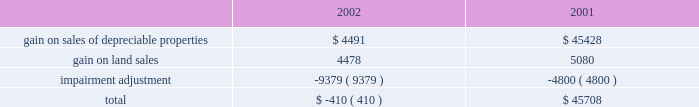Management 2019s discussion and analysis of financial conditionand results of operations d u k e r e a l t y c o r p o r a t i o n 1 1 2 0 0 2 a n n u a l r e p o r t 2022 interest expense on the company 2019s secured debt decreased from $ 30.8 million in 2001 to $ 22.9 million in 2002 as the company paid off $ 13.5 million of secured debt throughout 2002 and experienced lower borrowings on its secured line of credit during 2002 compared to 2001 .
Additionally , the company paid off approximately $ 128.5 million of secured debt throughout 2001 .
2022 interest expense on the company 2019s $ 500 million unsecured line of credit decreased by approximately $ 1.1 million in 2002 compared to 2001 as the company maintained lower balances on the line throughout most of 2002 .
As a result of the above-mentioned items , earnings from rental operations decreased $ 35.0 million from $ 254.1 million for the year ended december 31 , 2001 , to $ 219.1 million for the year ended december 31 , 2002 .
Service operations service operations primarily consist of leasing , management , construction and development services for joint venture properties and properties owned by third parties .
Service operations revenues decreased from $ 80.5 million for the year ended december 31 , 2001 , to $ 68.6 million for the year ended december 31 , 2002 .
The prolonged effect of the slow economy has been the primary factor in the overall decrease in revenues .
The company experienced a decrease of $ 12.7 million in net general contractor revenues because of a decrease in the volume of construction in 2002 , compared to 2001 , as well as slightly lower profit margins .
Property management , maintenance and leasing fee revenues decreased from $ 22.8 million in 2001 to $ 14.3 million in 2002 primarily because of a decrease in landscaping maintenance revenue resulting from the sale of the landscaping operations in the third quarter of 2001 .
Construction management and development activity income represents construction and development fees earned on projects where the company acts as the construction manager along with profits from the company 2019s held for sale program whereby the company develops a property for sale upon completion .
The increase in revenues of $ 10.3 million in 2002 is primarily due to an increase in volume of the sale of properties from the held for sale program .
Service operations expenses decreased from $ 45.3 million in 2001 to $ 38.3 million in 2002 .
The decrease is attributable to the decrease in construction and development activity and the reduced overhead costs as a result of the sale of the landscape business in 2001 .
As a result of the above , earnings from service operations decreased from $ 35.1 million for the year ended december 31 , 2001 , to $ 30.3 million for the year ended december 31 , 2002 .
General and administrative expense general and administrative expense increased from $ 15.6 million in 2001 to $ 25.4 million for the year ended december 31 , 2002 .
The company has been successful reducing total operating and administration costs ; however , reduced construction and development activities have resulted in a greater amount of overhead being charged to general and administrative expense instead of being capitalized into development projects or charged to service operations .
Other income and expenses gain on sale of land and depreciable property dispositions , net of impairment adjustment , is comprised of the following amounts in 2002 and 2001 : gain on sales of depreciable properties represent sales of previously held for investment rental properties .
Beginning in 2000 and continuing into 2001 , the company pursued favorable opportunities to dispose of real estate assets that no longer met long-term investment objectives .
In 2002 , the company significantly reduced this property sales program until the business climate improves and provides better investment opportunities for the sale proceeds .
Gain on land sales represents sales of undeveloped land owned by the company .
The company pursues opportunities to dispose of land in markets with a high concentration of undeveloped land and those markets where the land no longer meets strategic development plans of the company .
The company recorded a $ 9.4 million adjustment in 2002 associated with six properties determined to have an impairment of book value .
The company has analyzed each of its in-service properties and has determined that there are no additional valuation adjustments that need to be made as of december 31 , 2002 .
The company recorded an adjustment of $ 4.8 million in 2001 for one property that the company had contracted to sell for a price less than its book value .
Other revenue for the year ended december 31 , 2002 , includes $ 1.4 million of gain related to an interest rate swap that did not qualify for hedge accounting. .

What is the percent change in general and administrative expense from 2001 to 2002? 
Rationale: unable to synthesize table and text because it is unclear whether the table is in thousands or millions .
Computations: (((25.4 - 15.6) / 15.6) * 100)
Answer: 62.82051. 